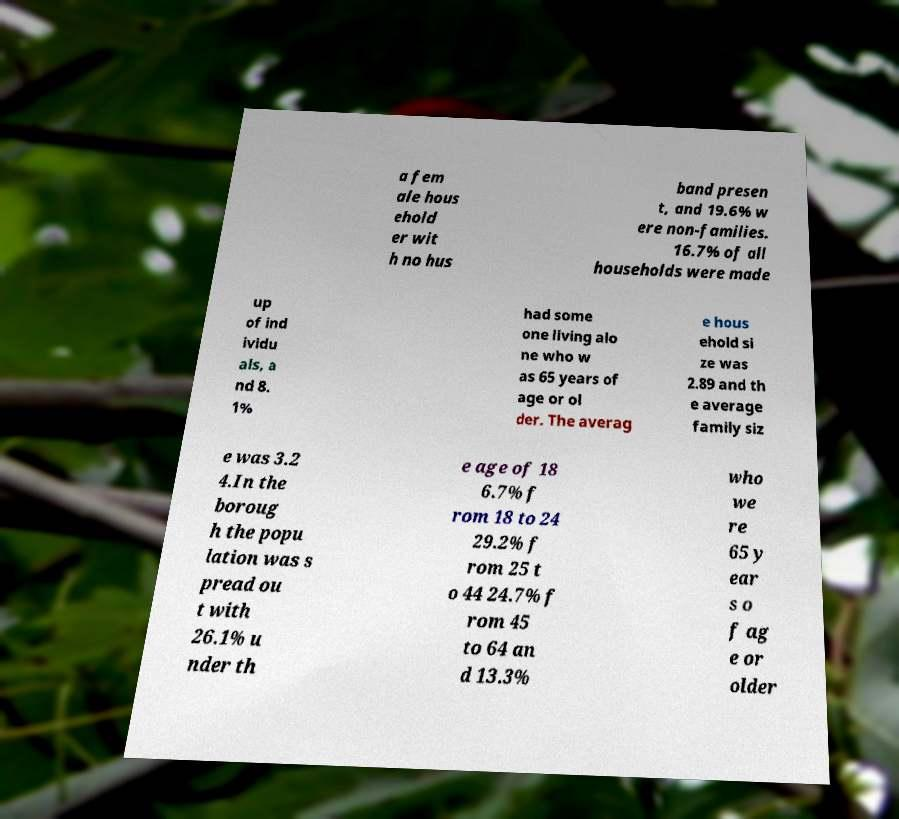Please identify and transcribe the text found in this image. a fem ale hous ehold er wit h no hus band presen t, and 19.6% w ere non-families. 16.7% of all households were made up of ind ividu als, a nd 8. 1% had some one living alo ne who w as 65 years of age or ol der. The averag e hous ehold si ze was 2.89 and th e average family siz e was 3.2 4.In the boroug h the popu lation was s pread ou t with 26.1% u nder th e age of 18 6.7% f rom 18 to 24 29.2% f rom 25 t o 44 24.7% f rom 45 to 64 an d 13.3% who we re 65 y ear s o f ag e or older 